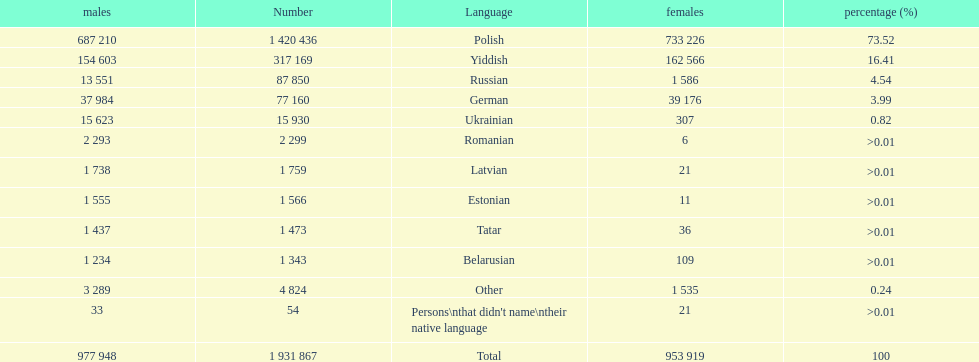In terms of speakers, which language has the largest population? Polish. 